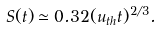Convert formula to latex. <formula><loc_0><loc_0><loc_500><loc_500>S ( t ) \simeq 0 . 3 2 ( u _ { t h } t ) ^ { 2 / 3 } .</formula> 